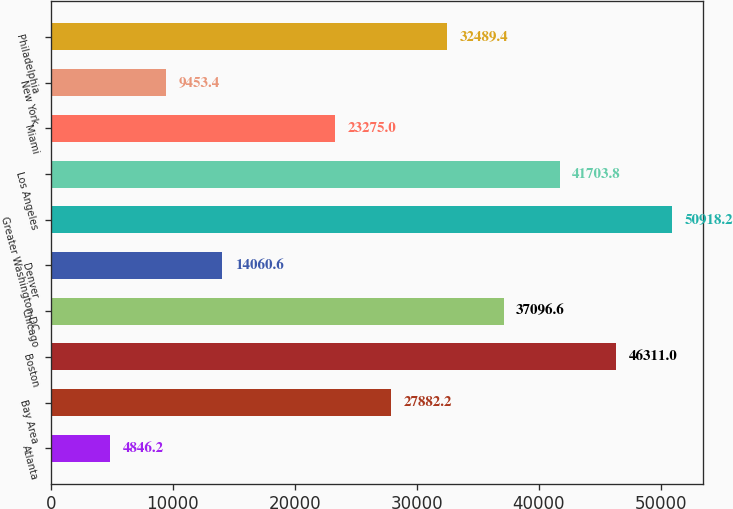Convert chart to OTSL. <chart><loc_0><loc_0><loc_500><loc_500><bar_chart><fcel>Atlanta<fcel>Bay Area<fcel>Boston<fcel>Chicago<fcel>Denver<fcel>Greater Washington DC<fcel>Los Angeles<fcel>Miami<fcel>New York<fcel>Philadelphia<nl><fcel>4846.2<fcel>27882.2<fcel>46311<fcel>37096.6<fcel>14060.6<fcel>50918.2<fcel>41703.8<fcel>23275<fcel>9453.4<fcel>32489.4<nl></chart> 